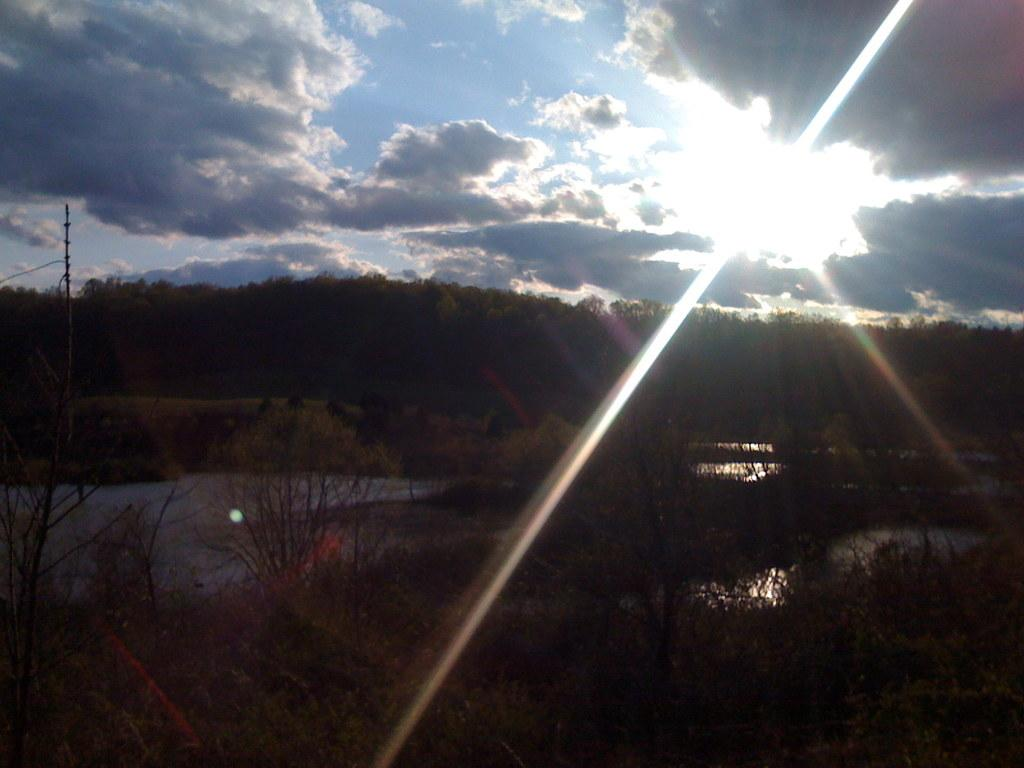What natural element is visible in the image? Water is visible in the image. What type of vegetation can be seen in the image? There are trees in the image. What is the man-made object present in the image? There is a pole in the image. What is visible in the background of the image? The sky with clouds is visible in the background of the image. How does the development of the area affect the mind of the trees in the image? There is no development or mind present in the image; it features water, trees, a pole, and the sky with clouds. 